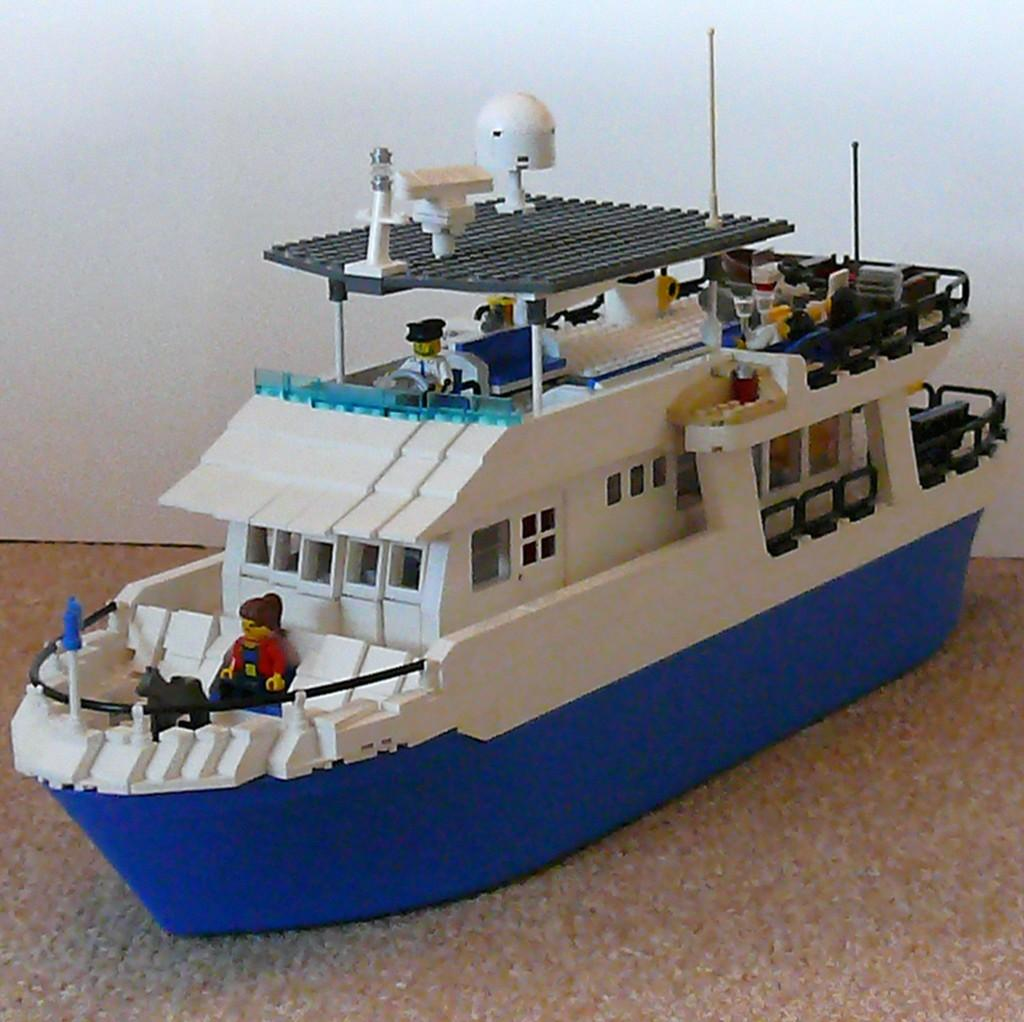What is the main object in the image? There is a toy ship in the image. What can be seen in the background of the image? There is a wall visible in the background of the image. What type of fuel is being used by the toy ship in the image? There is no fuel involved in the toy ship, as it is not a real ship and does not require fuel to operate. 